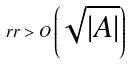Convert formula to latex. <formula><loc_0><loc_0><loc_500><loc_500>\ r r > O \left ( \sqrt { | A | } \right )</formula> 